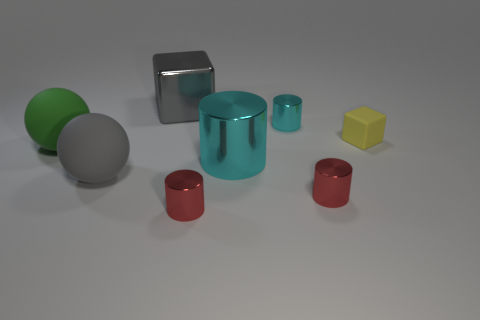Add 1 purple metallic things. How many objects exist? 9 Subtract all small cyan cylinders. How many cylinders are left? 3 Subtract all cyan blocks. How many cyan cylinders are left? 2 Subtract all green balls. How many balls are left? 1 Add 5 big things. How many big things are left? 9 Add 7 green rubber things. How many green rubber things exist? 8 Subtract 1 gray blocks. How many objects are left? 7 Subtract all cubes. How many objects are left? 6 Subtract 2 balls. How many balls are left? 0 Subtract all yellow balls. Subtract all red cylinders. How many balls are left? 2 